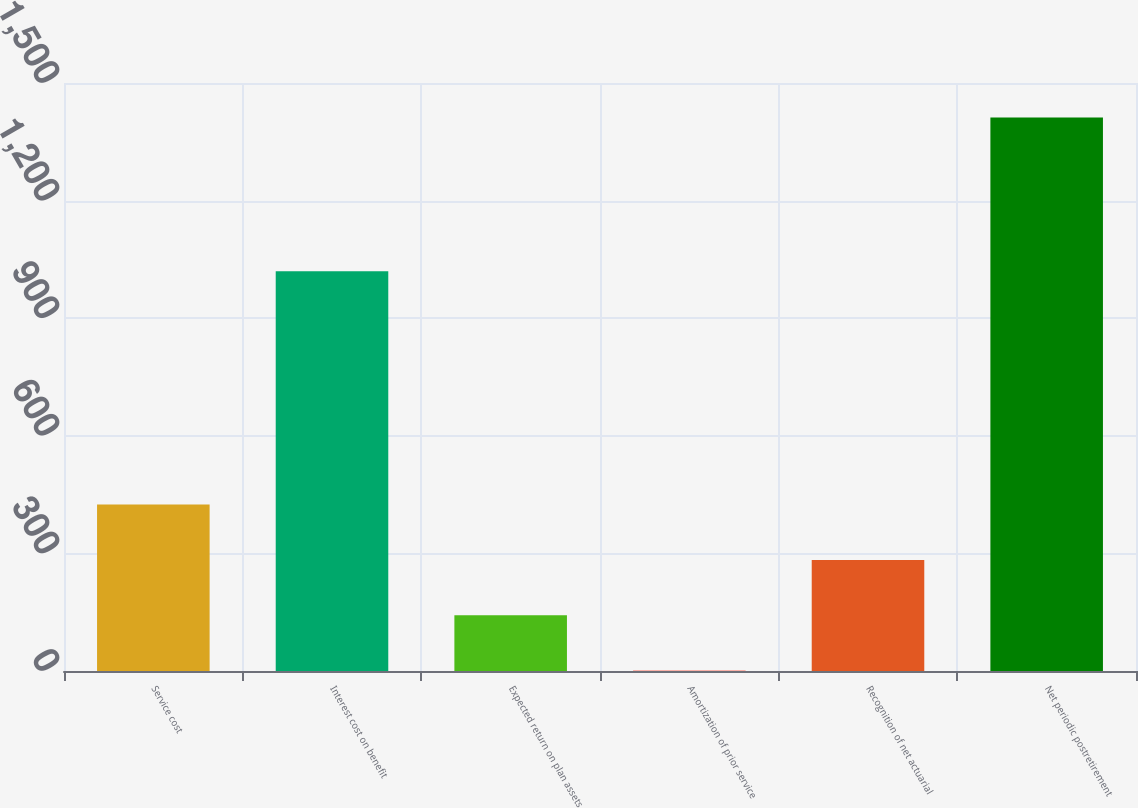Convert chart to OTSL. <chart><loc_0><loc_0><loc_500><loc_500><bar_chart><fcel>Service cost<fcel>Interest cost on benefit<fcel>Expected return on plan assets<fcel>Amortization of prior service<fcel>Recognition of net actuarial<fcel>Net periodic postretirement<nl><fcel>424.54<fcel>1020<fcel>142.42<fcel>1.36<fcel>283.48<fcel>1412<nl></chart> 